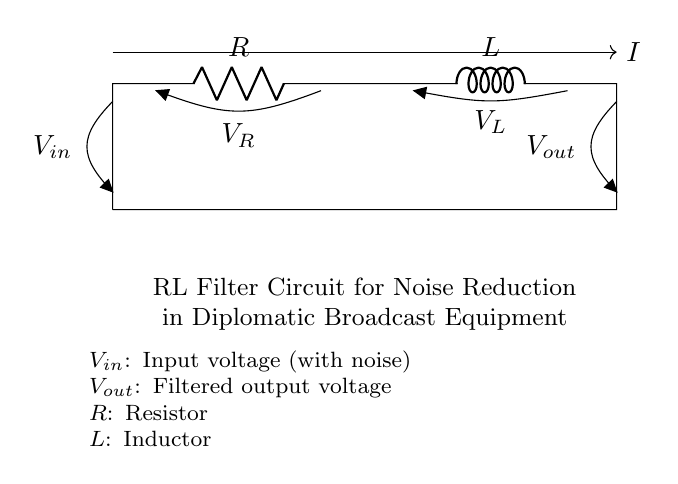What components are in this circuit? The circuit contains a resistor and an inductor, which are vital components for filtering noise. The resistor is marked as R and the inductor as L in the diagram.
Answer: Resistor and Inductor What does V_in represent in the circuit? V_in is noted as the input voltage with noise, indicating the starting point of the voltage that is being filtered. This is shown by the label next to the connection at the top left.
Answer: Input voltage with noise What is the purpose of the RL filter circuit? The purpose of the RL filter circuit is to reduce noise in the output voltage, reflecting its application in diplomatic broadcast equipment. This is indicated in the descriptive text below the circuit.
Answer: Noise reduction How does current flow in this circuit? Current flows from the input voltage V_in towards the output voltage V_out through the resistor and inductor. The current direction is indicated by the arrow labeled I on the circuit.
Answer: From V_in to V_out What will happen to the output voltage over time? The output voltage will gradually stabilize as the inductor resists sudden changes, causing a smoothing effect on the output voltage by filtering out rapid fluctuations. This is a known behavior of RL circuits.
Answer: Stabilize over time What effect does the inductor have in this circuit? The inductor introduces inductance which helps in filtering high-frequency noise by opposing changes in current. This dynamic is characteristic of inductors in RL circuits, influencing the overall frequency response.
Answer: Filters high-frequency noise What is the relationship between V_R and V_L in this RL circuit? The relationship is based on Kirchhoff's voltage law, which states that the sum of voltages across the components must equal the input voltage V_in, with V_R and V_L complementing each other in behavior.
Answer: V_R + V_L = V_in 